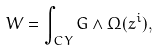<formula> <loc_0><loc_0><loc_500><loc_500>W = \int _ { C Y } G \wedge \Omega ( z ^ { i } ) ,</formula> 